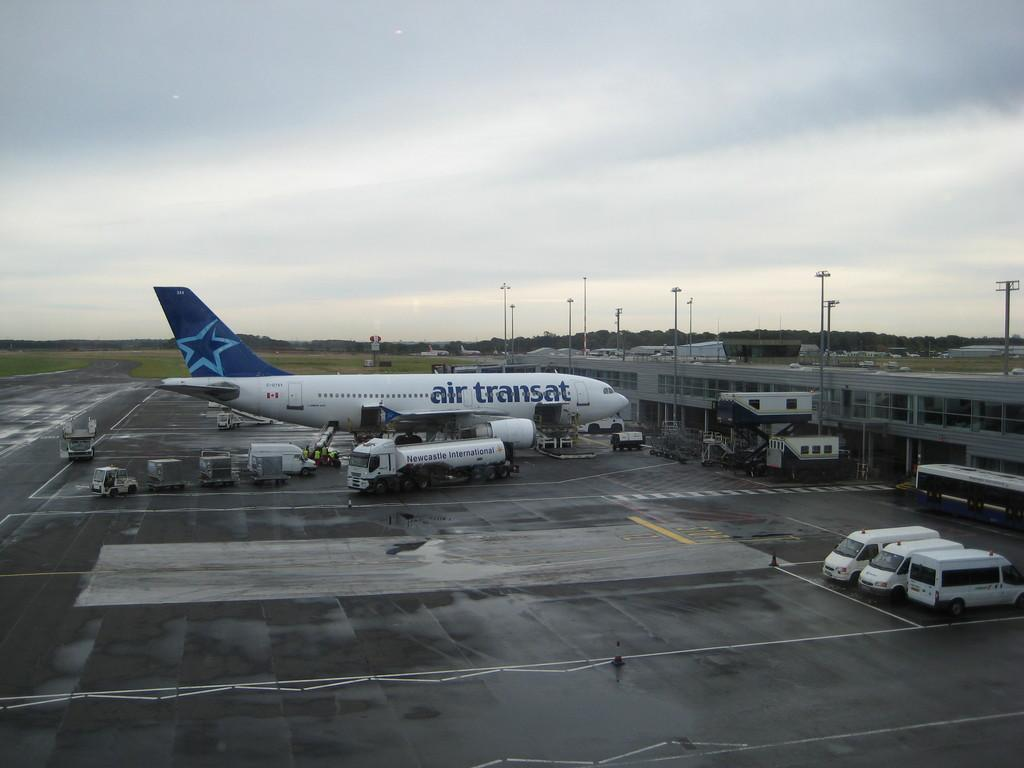<image>
Create a compact narrative representing the image presented. a plane in a hanger with Air Transat on the side 